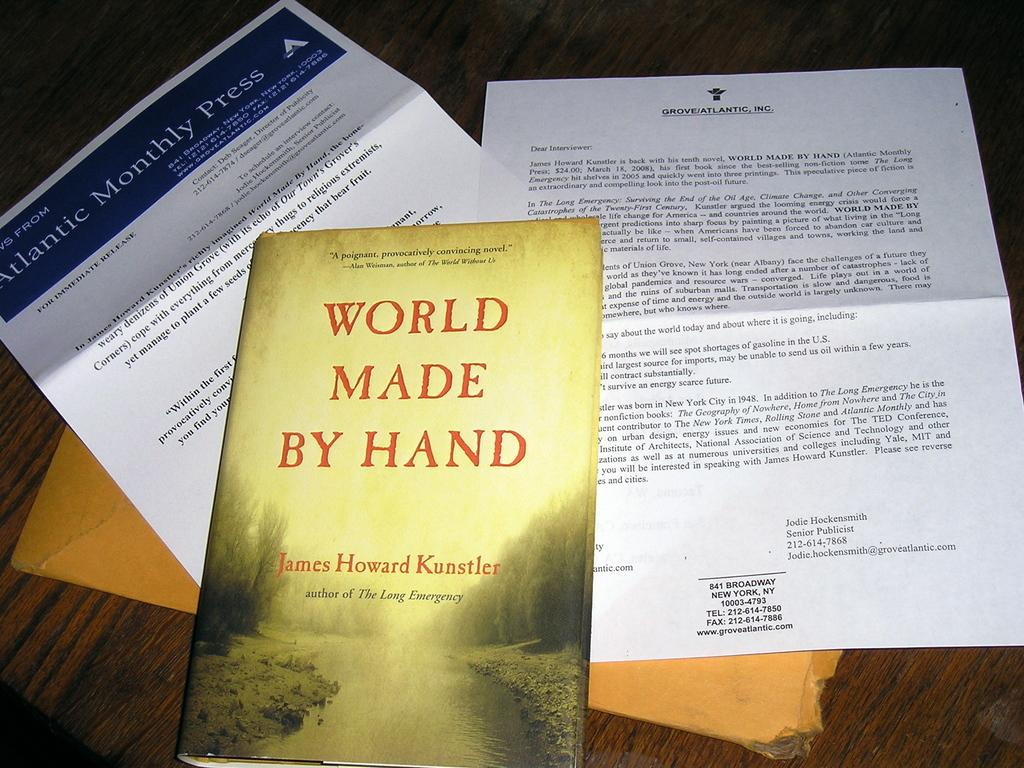<image>
Create a compact narrative representing the image presented. A book on a table is titled World Made By Hand. 